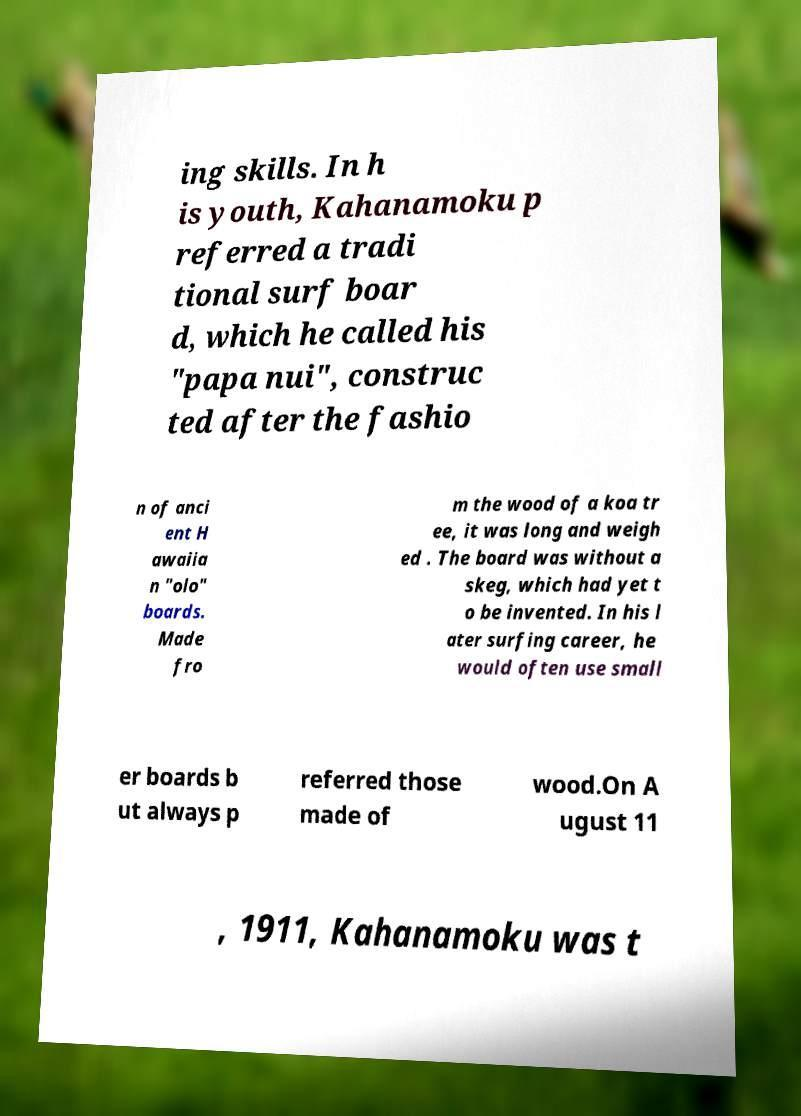Please identify and transcribe the text found in this image. ing skills. In h is youth, Kahanamoku p referred a tradi tional surf boar d, which he called his "papa nui", construc ted after the fashio n of anci ent H awaiia n "olo" boards. Made fro m the wood of a koa tr ee, it was long and weigh ed . The board was without a skeg, which had yet t o be invented. In his l ater surfing career, he would often use small er boards b ut always p referred those made of wood.On A ugust 11 , 1911, Kahanamoku was t 